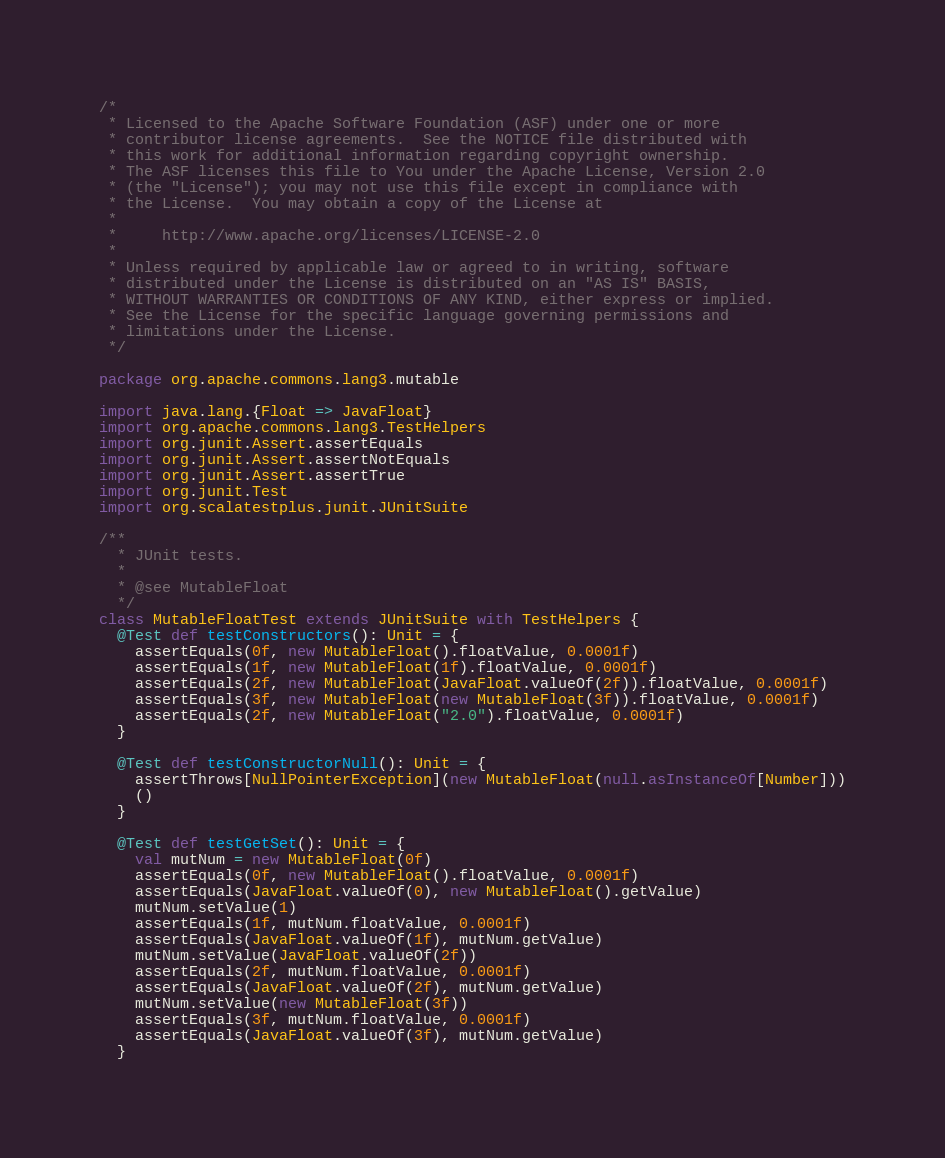Convert code to text. <code><loc_0><loc_0><loc_500><loc_500><_Scala_>/*
 * Licensed to the Apache Software Foundation (ASF) under one or more
 * contributor license agreements.  See the NOTICE file distributed with
 * this work for additional information regarding copyright ownership.
 * The ASF licenses this file to You under the Apache License, Version 2.0
 * (the "License"); you may not use this file except in compliance with
 * the License.  You may obtain a copy of the License at
 *
 *     http://www.apache.org/licenses/LICENSE-2.0
 *
 * Unless required by applicable law or agreed to in writing, software
 * distributed under the License is distributed on an "AS IS" BASIS,
 * WITHOUT WARRANTIES OR CONDITIONS OF ANY KIND, either express or implied.
 * See the License for the specific language governing permissions and
 * limitations under the License.
 */

package org.apache.commons.lang3.mutable

import java.lang.{Float => JavaFloat}
import org.apache.commons.lang3.TestHelpers
import org.junit.Assert.assertEquals
import org.junit.Assert.assertNotEquals
import org.junit.Assert.assertTrue
import org.junit.Test
import org.scalatestplus.junit.JUnitSuite

/**
  * JUnit tests.
  *
  * @see MutableFloat
  */
class MutableFloatTest extends JUnitSuite with TestHelpers {
  @Test def testConstructors(): Unit = {
    assertEquals(0f, new MutableFloat().floatValue, 0.0001f)
    assertEquals(1f, new MutableFloat(1f).floatValue, 0.0001f)
    assertEquals(2f, new MutableFloat(JavaFloat.valueOf(2f)).floatValue, 0.0001f)
    assertEquals(3f, new MutableFloat(new MutableFloat(3f)).floatValue, 0.0001f)
    assertEquals(2f, new MutableFloat("2.0").floatValue, 0.0001f)
  }

  @Test def testConstructorNull(): Unit = {
    assertThrows[NullPointerException](new MutableFloat(null.asInstanceOf[Number]))
    ()
  }

  @Test def testGetSet(): Unit = {
    val mutNum = new MutableFloat(0f)
    assertEquals(0f, new MutableFloat().floatValue, 0.0001f)
    assertEquals(JavaFloat.valueOf(0), new MutableFloat().getValue)
    mutNum.setValue(1)
    assertEquals(1f, mutNum.floatValue, 0.0001f)
    assertEquals(JavaFloat.valueOf(1f), mutNum.getValue)
    mutNum.setValue(JavaFloat.valueOf(2f))
    assertEquals(2f, mutNum.floatValue, 0.0001f)
    assertEquals(JavaFloat.valueOf(2f), mutNum.getValue)
    mutNum.setValue(new MutableFloat(3f))
    assertEquals(3f, mutNum.floatValue, 0.0001f)
    assertEquals(JavaFloat.valueOf(3f), mutNum.getValue)
  }
</code> 